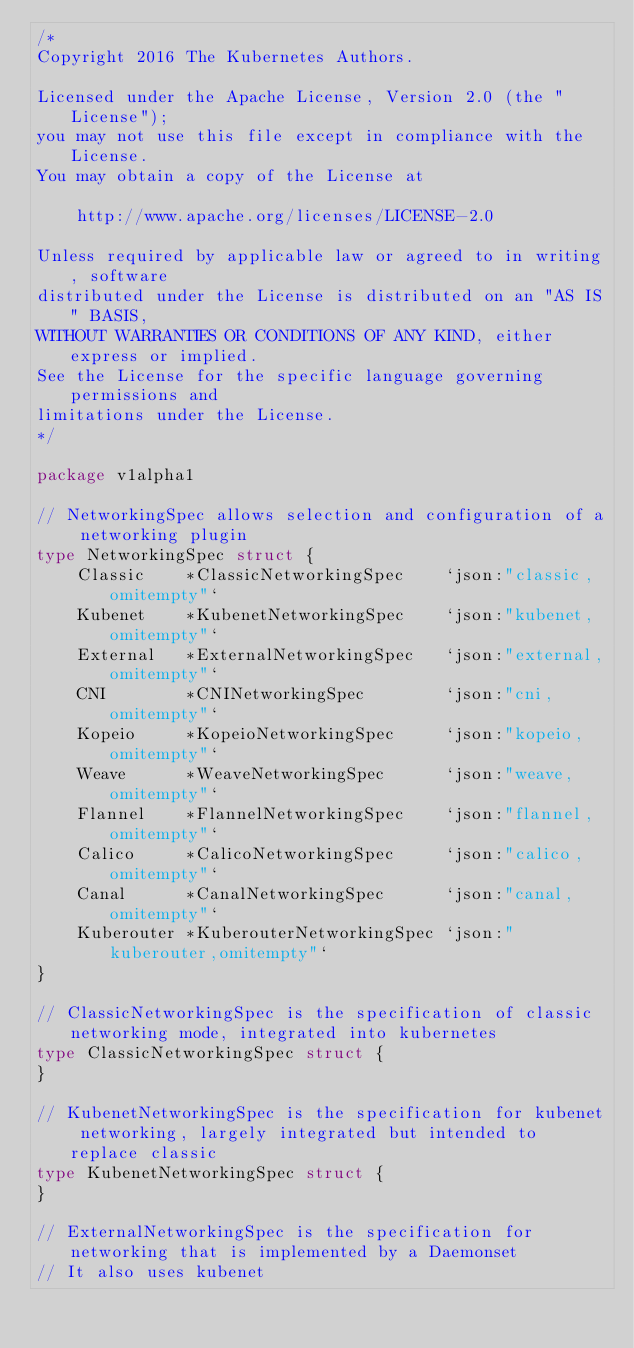Convert code to text. <code><loc_0><loc_0><loc_500><loc_500><_Go_>/*
Copyright 2016 The Kubernetes Authors.

Licensed under the Apache License, Version 2.0 (the "License");
you may not use this file except in compliance with the License.
You may obtain a copy of the License at

    http://www.apache.org/licenses/LICENSE-2.0

Unless required by applicable law or agreed to in writing, software
distributed under the License is distributed on an "AS IS" BASIS,
WITHOUT WARRANTIES OR CONDITIONS OF ANY KIND, either express or implied.
See the License for the specific language governing permissions and
limitations under the License.
*/

package v1alpha1

// NetworkingSpec allows selection and configuration of a networking plugin
type NetworkingSpec struct {
	Classic    *ClassicNetworkingSpec    `json:"classic,omitempty"`
	Kubenet    *KubenetNetworkingSpec    `json:"kubenet,omitempty"`
	External   *ExternalNetworkingSpec   `json:"external,omitempty"`
	CNI        *CNINetworkingSpec        `json:"cni,omitempty"`
	Kopeio     *KopeioNetworkingSpec     `json:"kopeio,omitempty"`
	Weave      *WeaveNetworkingSpec      `json:"weave,omitempty"`
	Flannel    *FlannelNetworkingSpec    `json:"flannel,omitempty"`
	Calico     *CalicoNetworkingSpec     `json:"calico,omitempty"`
	Canal      *CanalNetworkingSpec      `json:"canal,omitempty"`
	Kuberouter *KuberouterNetworkingSpec `json:"kuberouter,omitempty"`
}

// ClassicNetworkingSpec is the specification of classic networking mode, integrated into kubernetes
type ClassicNetworkingSpec struct {
}

// KubenetNetworkingSpec is the specification for kubenet networking, largely integrated but intended to replace classic
type KubenetNetworkingSpec struct {
}

// ExternalNetworkingSpec is the specification for networking that is implemented by a Daemonset
// It also uses kubenet</code> 